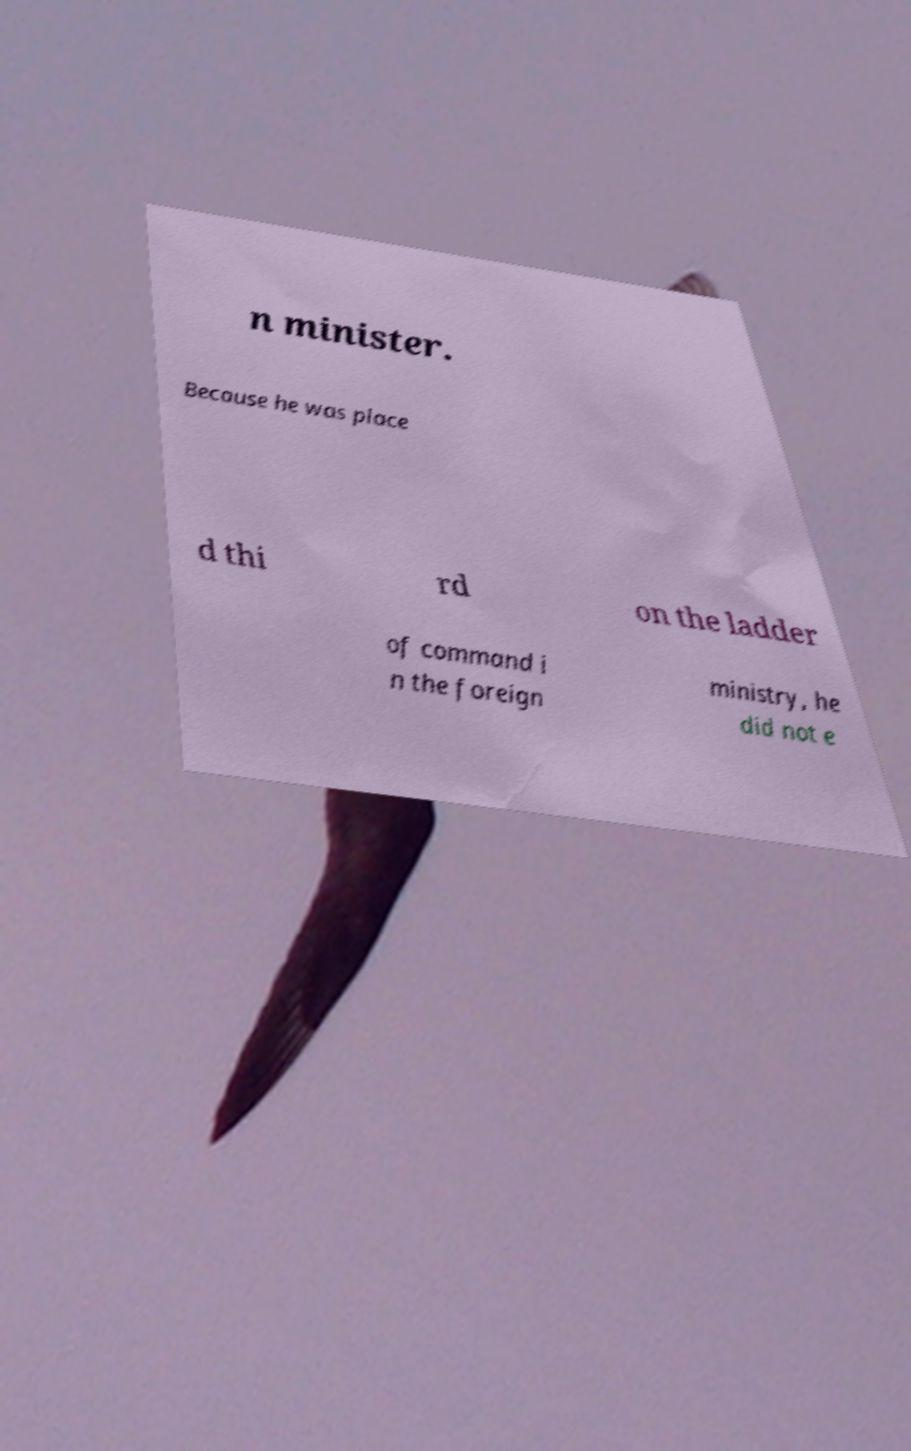For documentation purposes, I need the text within this image transcribed. Could you provide that? n minister. Because he was place d thi rd on the ladder of command i n the foreign ministry, he did not e 